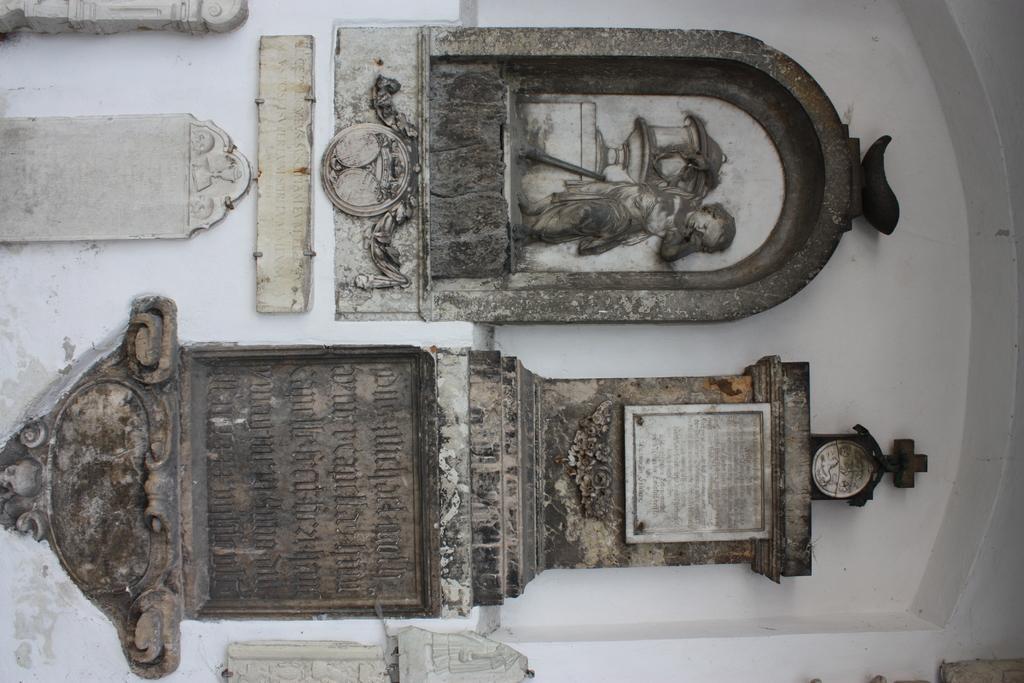Describe this image in one or two sentences. In this image, we can see a sculpture and name stone on the wall. 